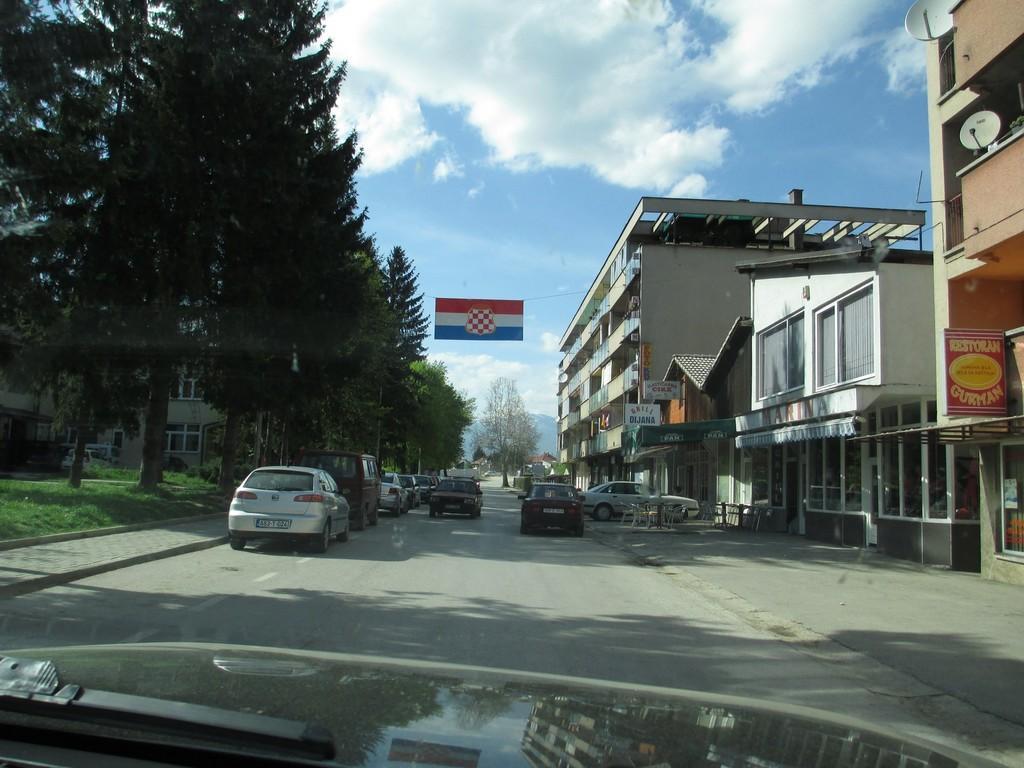Describe this image in one or two sentences. In this image at the bottom there might be a vehicle part, in the middle there is a road , there are some vehicles visible, on the right side there are some buildings, chairs kept on it, on the left side there are trees, chairs, vehicle, at the top there is the sky,. 